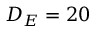<formula> <loc_0><loc_0><loc_500><loc_500>D _ { E } = 2 0</formula> 